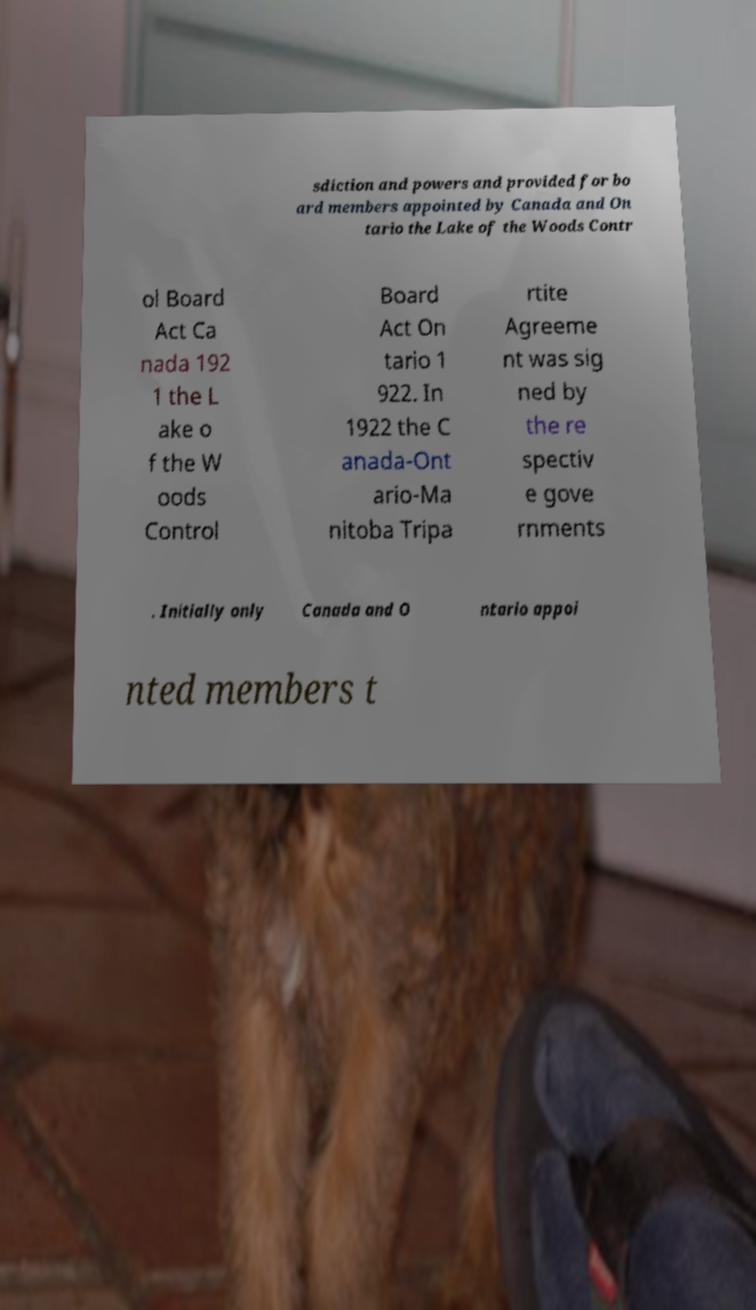Can you accurately transcribe the text from the provided image for me? sdiction and powers and provided for bo ard members appointed by Canada and On tario the Lake of the Woods Contr ol Board Act Ca nada 192 1 the L ake o f the W oods Control Board Act On tario 1 922. In 1922 the C anada-Ont ario-Ma nitoba Tripa rtite Agreeme nt was sig ned by the re spectiv e gove rnments . Initially only Canada and O ntario appoi nted members t 